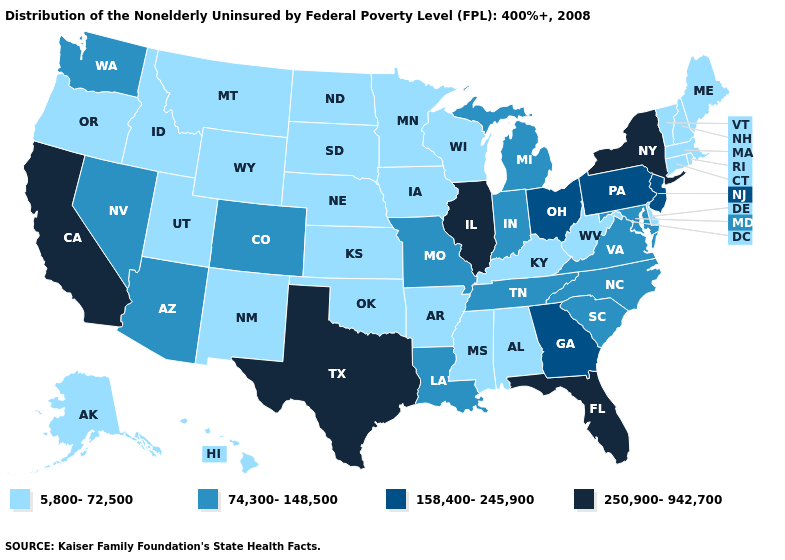How many symbols are there in the legend?
Give a very brief answer. 4. Among the states that border California , does Oregon have the lowest value?
Give a very brief answer. Yes. Among the states that border Arizona , does New Mexico have the lowest value?
Keep it brief. Yes. Name the states that have a value in the range 158,400-245,900?
Be succinct. Georgia, New Jersey, Ohio, Pennsylvania. Among the states that border Arizona , does California have the highest value?
Give a very brief answer. Yes. What is the value of Maryland?
Short answer required. 74,300-148,500. Name the states that have a value in the range 158,400-245,900?
Quick response, please. Georgia, New Jersey, Ohio, Pennsylvania. What is the value of New York?
Write a very short answer. 250,900-942,700. Name the states that have a value in the range 5,800-72,500?
Keep it brief. Alabama, Alaska, Arkansas, Connecticut, Delaware, Hawaii, Idaho, Iowa, Kansas, Kentucky, Maine, Massachusetts, Minnesota, Mississippi, Montana, Nebraska, New Hampshire, New Mexico, North Dakota, Oklahoma, Oregon, Rhode Island, South Dakota, Utah, Vermont, West Virginia, Wisconsin, Wyoming. Which states have the lowest value in the USA?
Be succinct. Alabama, Alaska, Arkansas, Connecticut, Delaware, Hawaii, Idaho, Iowa, Kansas, Kentucky, Maine, Massachusetts, Minnesota, Mississippi, Montana, Nebraska, New Hampshire, New Mexico, North Dakota, Oklahoma, Oregon, Rhode Island, South Dakota, Utah, Vermont, West Virginia, Wisconsin, Wyoming. What is the lowest value in states that border Florida?
Give a very brief answer. 5,800-72,500. How many symbols are there in the legend?
Write a very short answer. 4. Which states have the lowest value in the USA?
Concise answer only. Alabama, Alaska, Arkansas, Connecticut, Delaware, Hawaii, Idaho, Iowa, Kansas, Kentucky, Maine, Massachusetts, Minnesota, Mississippi, Montana, Nebraska, New Hampshire, New Mexico, North Dakota, Oklahoma, Oregon, Rhode Island, South Dakota, Utah, Vermont, West Virginia, Wisconsin, Wyoming. What is the highest value in the USA?
Be succinct. 250,900-942,700. What is the value of New York?
Quick response, please. 250,900-942,700. 